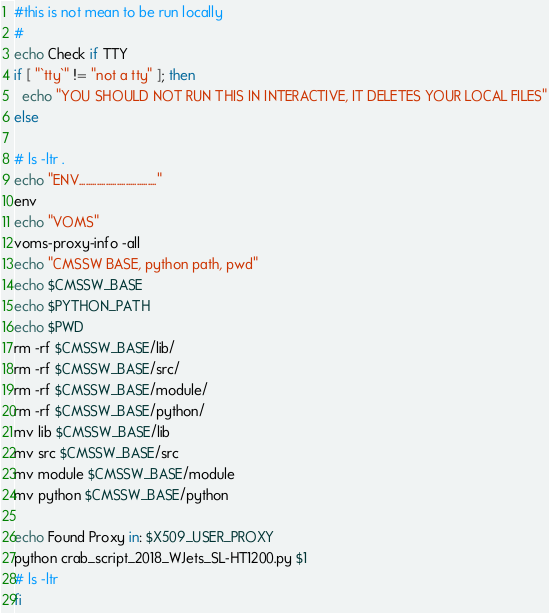<code> <loc_0><loc_0><loc_500><loc_500><_Bash_>#this is not mean to be run locally
#
echo Check if TTY
if [ "`tty`" != "not a tty" ]; then
  echo "YOU SHOULD NOT RUN THIS IN INTERACTIVE, IT DELETES YOUR LOCAL FILES"
else

# ls -ltr .
echo "ENV..................................."
env 
echo "VOMS"
voms-proxy-info -all
echo "CMSSW BASE, python path, pwd"
echo $CMSSW_BASE 
echo $PYTHON_PATH
echo $PWD 
rm -rf $CMSSW_BASE/lib/
rm -rf $CMSSW_BASE/src/
rm -rf $CMSSW_BASE/module/
rm -rf $CMSSW_BASE/python/
mv lib $CMSSW_BASE/lib
mv src $CMSSW_BASE/src
mv module $CMSSW_BASE/module
mv python $CMSSW_BASE/python

echo Found Proxy in: $X509_USER_PROXY
python crab_script_2018_WJets_SL-HT1200.py $1
# ls -ltr
fi
</code> 